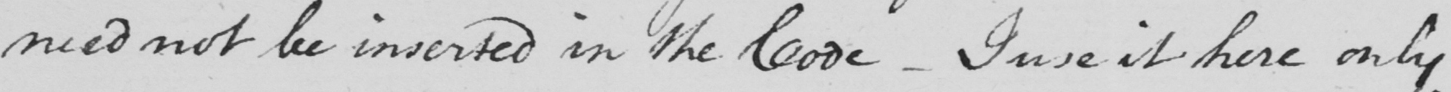Please provide the text content of this handwritten line. need not be inserted in the Code  _  I use it here only 